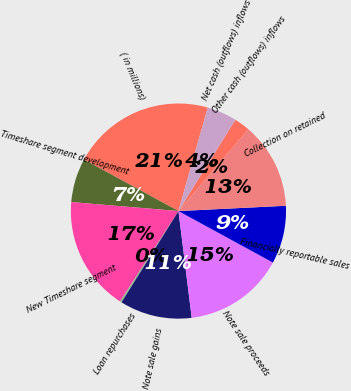<chart> <loc_0><loc_0><loc_500><loc_500><pie_chart><fcel>( in millions)<fcel>Timeshare segment development<fcel>New Timeshare segment<fcel>Loan repurchases<fcel>Note sale gains<fcel>Note sale proceeds<fcel>Financially reportable sales<fcel>Collection on retained<fcel>Other cash (outflows) inflows<fcel>Net cash (outflows) inflows<nl><fcel>21.45%<fcel>6.61%<fcel>17.21%<fcel>0.25%<fcel>10.85%<fcel>15.09%<fcel>8.73%<fcel>12.97%<fcel>2.37%<fcel>4.49%<nl></chart> 